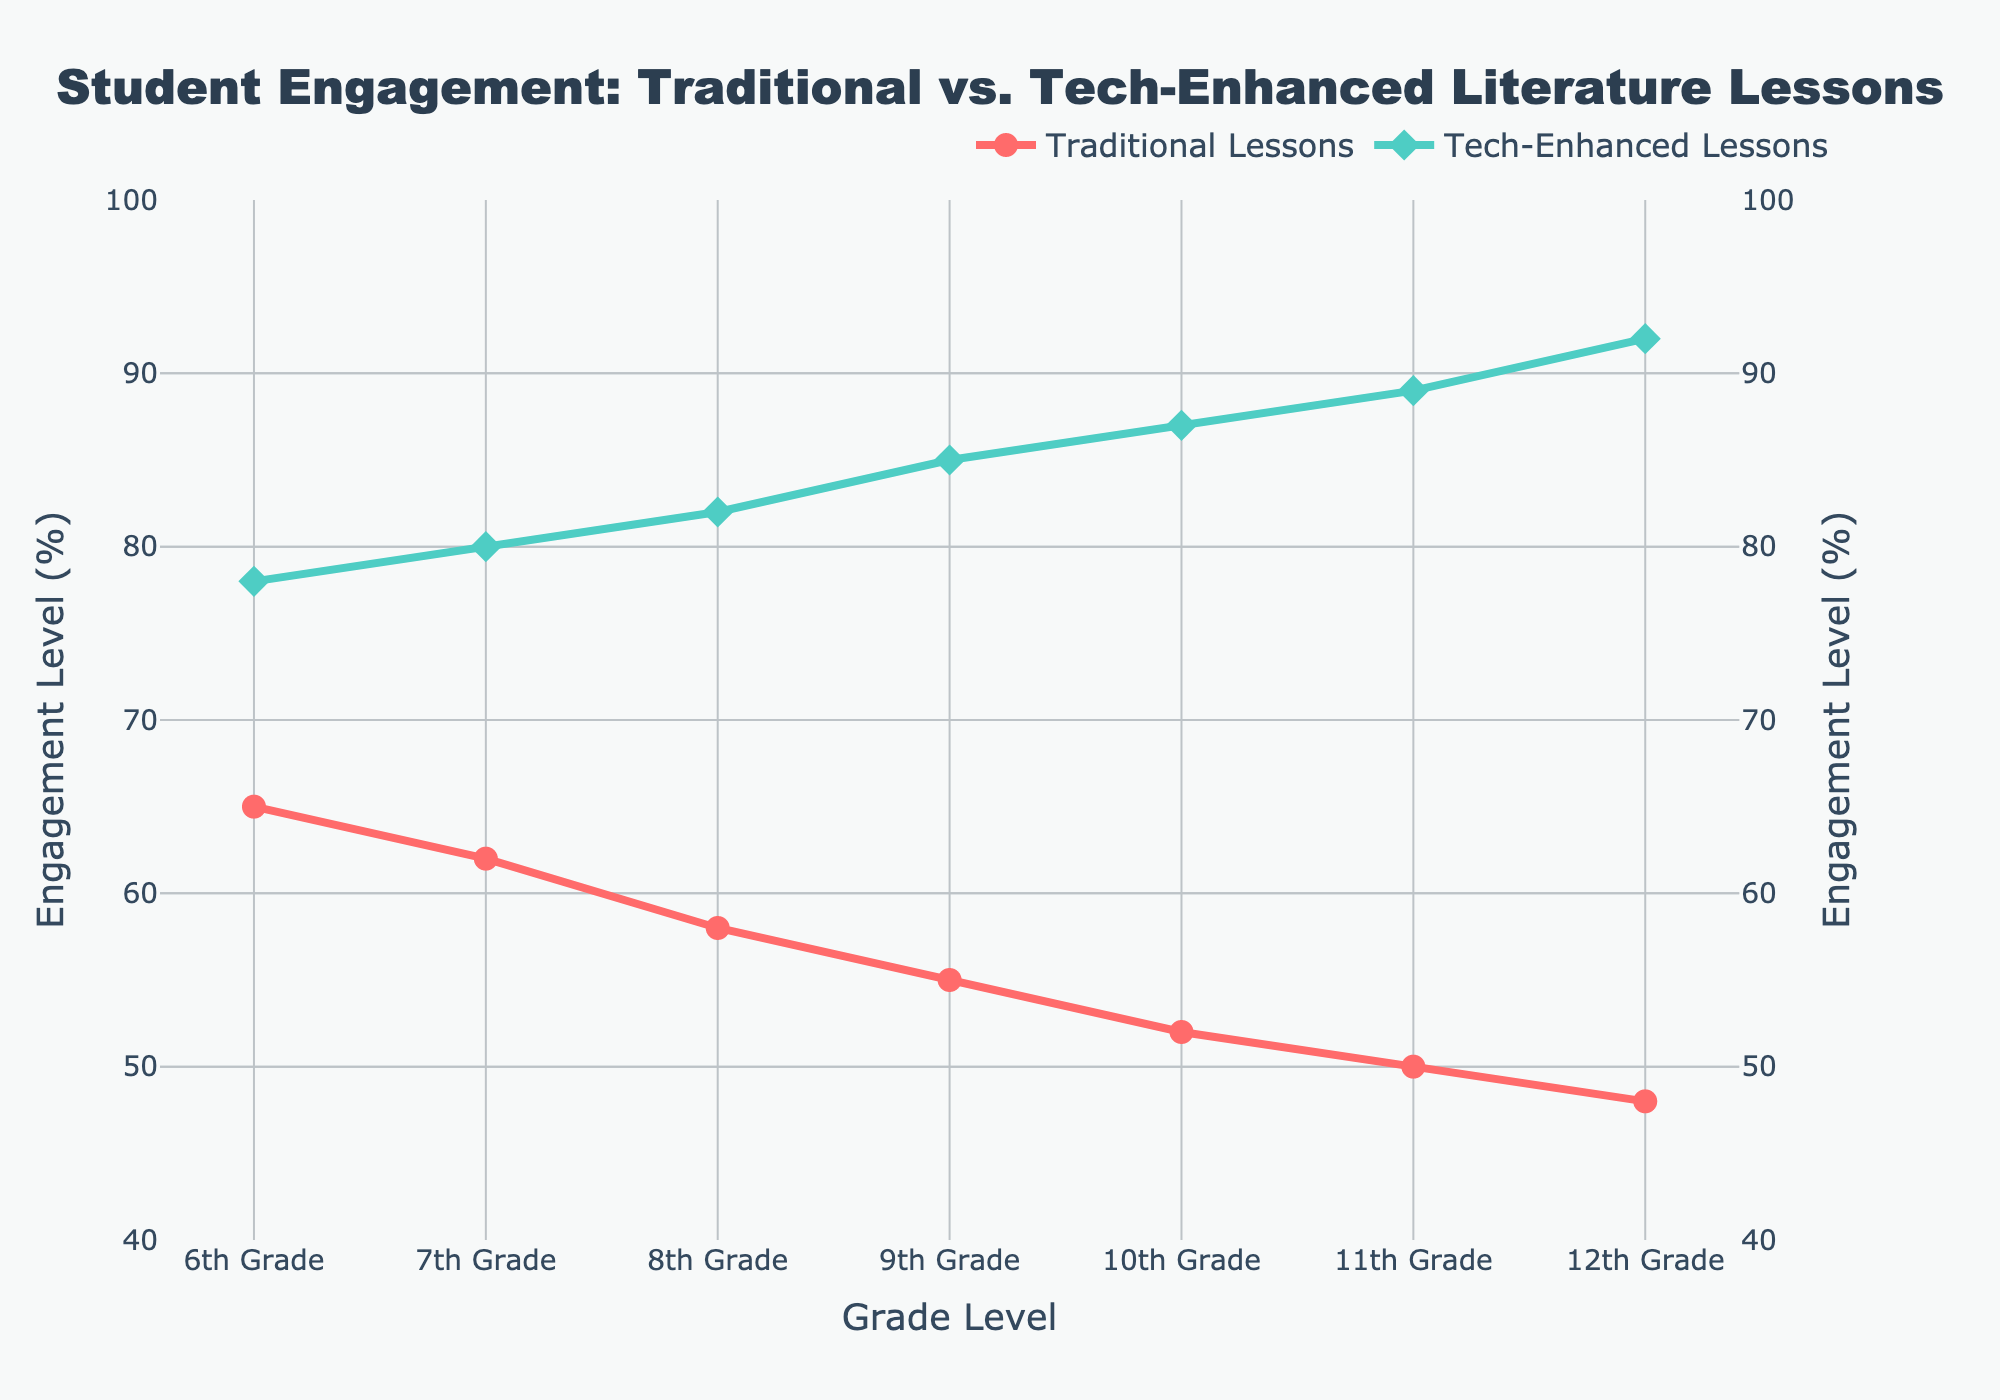What's the difference in student engagement levels between Traditional and Tech-Enhanced Lessons for 6th Grade? The engagement level for 6th Grade in Traditional Lessons is 65%, and for Tech-Enhanced Lessons, it is 78%. The difference is calculated as 78% - 65% = 13%.
Answer: 13% What is the average student engagement level for both Traditional and Tech-Enhanced Lessons across all grade levels? For Traditional Lessons: (65 + 62 + 58 + 55 + 52 + 50 + 48)/7 ≈ 55.71%. For Tech-Enhanced Lessons: (78 + 80 + 82 + 85 + 87 + 89 + 92)/7 ≈ 84.71%. The overall average is (55.71% + 84.71%)/2 ≈ 70.21%.
Answer: 70.21% Which grade level shows the highest student engagement in Tech-Enhanced Lessons? By looking at the chart, the highest engagement for Tech-Enhanced Lessons is in 12th Grade at 92%.
Answer: 12th Grade How much lower is the student engagement level in Traditional Lessons compared to Tech-Enhanced Lessons for 9th Grade? For 9th Grade, Traditional Lessons have 55% and Tech-Enhanced Lessons have 85%. The difference is 85% - 55% = 30%.
Answer: 30% Which lessons have a narrower range of engagement levels across grade levels? The range for Traditional Lessons is 65% - 48% = 17%. The range for Tech-Enhanced Lessons is 92% - 78% = 14%. Therefore, Tech-Enhanced Lessons have a narrower range.
Answer: Tech-Enhanced Lessons For which grade level is the engagement in Tech-Enhanced Lessons double that of Traditional Lessons? For 12th Grade, the engagement in Tech-Enhanced Lessons is 92%, and in Traditional Lessons, it is 48%. Given that 48% * 2 = 96% and since 92% is close to that value, it suggests that 12th Grade almost meets this condition.
Answer: 12th Grade What is the overall trend in student engagement levels from 6th to 12th Grade in both lesson types? The trend is that student engagement decreases from 6th to 12th Grade in Traditional Lessons, whereas it increases in Tech-Enhanced Lessons.
Answer: Engagement decreases in Traditional and increases in Tech-Enhanced Which grade level has the smallest difference in engagement levels between Traditional and Tech-Enhanced Lessons? Look at the differences for each grade level: 6th (13%), 7th (18%), 8th (24%), 9th (30%), 10th (35%), 11th (39%), 12th (44%). The smallest difference is in 6th Grade with 13%.
Answer: 6th Grade What percentage of engagement does 11th Grade have in Traditional Lessons compared to Tech-Enhanced Lessons? In 11th Grade, Traditional Lessons have 50% engagement, while Tech-Enhanced Lessons have 89%. The percentage of Traditional to Tech-Enhanced is (50/89) * 100 ≈ 56.18%.
Answer: 56.18% 